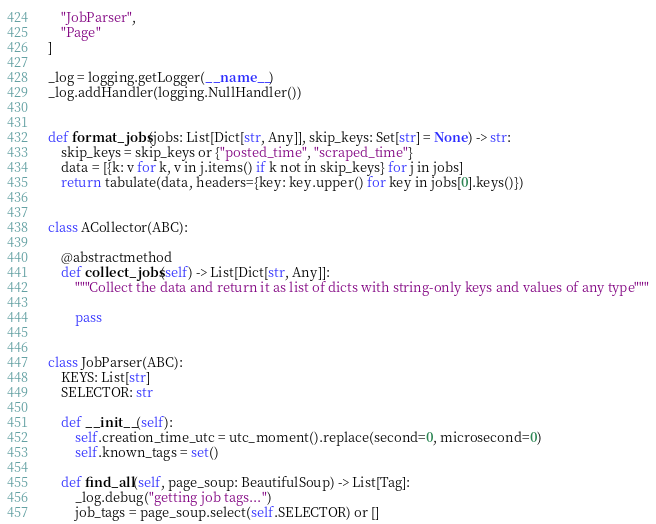<code> <loc_0><loc_0><loc_500><loc_500><_Python_>    "JobParser",
    "Page"
]

_log = logging.getLogger(__name__)
_log.addHandler(logging.NullHandler())


def format_jobs(jobs: List[Dict[str, Any]], skip_keys: Set[str] = None) -> str:
    skip_keys = skip_keys or {"posted_time", "scraped_time"}
    data = [{k: v for k, v in j.items() if k not in skip_keys} for j in jobs]
    return tabulate(data, headers={key: key.upper() for key in jobs[0].keys()})


class ACollector(ABC):

    @abstractmethod
    def collect_jobs(self) -> List[Dict[str, Any]]:
        """Collect the data and return it as list of dicts with string-only keys and values of any type"""

        pass


class JobParser(ABC):
    KEYS: List[str]
    SELECTOR: str

    def __init__(self):
        self.creation_time_utc = utc_moment().replace(second=0, microsecond=0)
        self.known_tags = set()

    def find_all(self, page_soup: BeautifulSoup) -> List[Tag]:
        _log.debug("getting job tags...")
        job_tags = page_soup.select(self.SELECTOR) or []</code> 